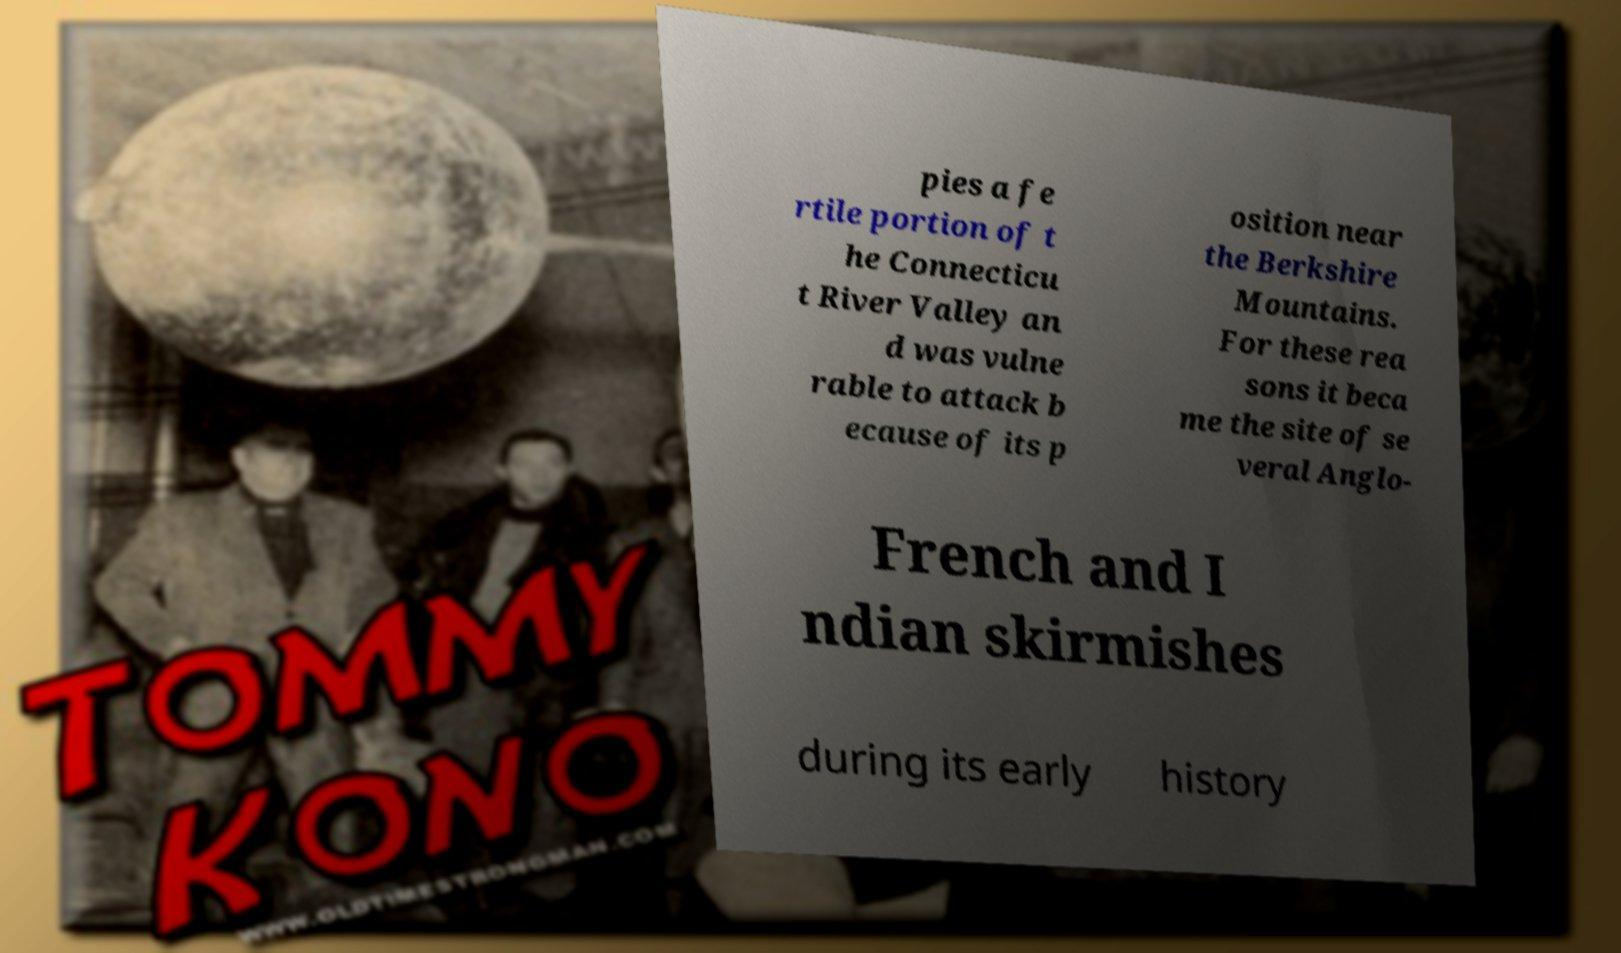There's text embedded in this image that I need extracted. Can you transcribe it verbatim? pies a fe rtile portion of t he Connecticu t River Valley an d was vulne rable to attack b ecause of its p osition near the Berkshire Mountains. For these rea sons it beca me the site of se veral Anglo- French and I ndian skirmishes during its early history 